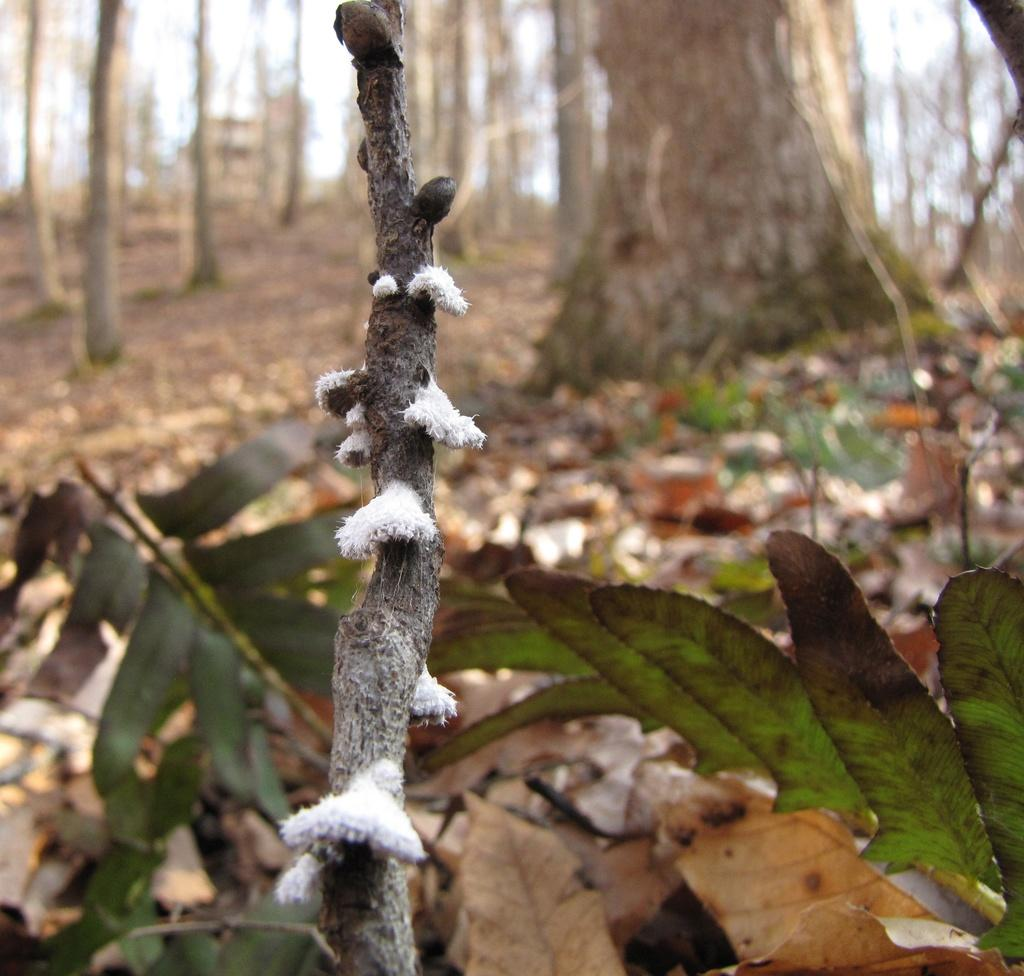What is the primary focus of the image? The primary focus of the image is the bark of a tree. What type of vegetation can be seen in the image? Dried leaves and green color leaves are visible in the image. How would you describe the background of the image? The background of the image is blurry. Are there any other tree-related elements in the background? Yes, some parts of the background contain barks of trees. What type of range is visible in the image? There is no range present in the image; it features the bark of a tree, dried leaves, green color leaves, and a blurry background. Can you tell me how many cannons are hidden behind the tree bark in the image? There are no cannons present in the image; it only contains the bark of a tree, dried leaves, green color leaves, and a blurry background. 